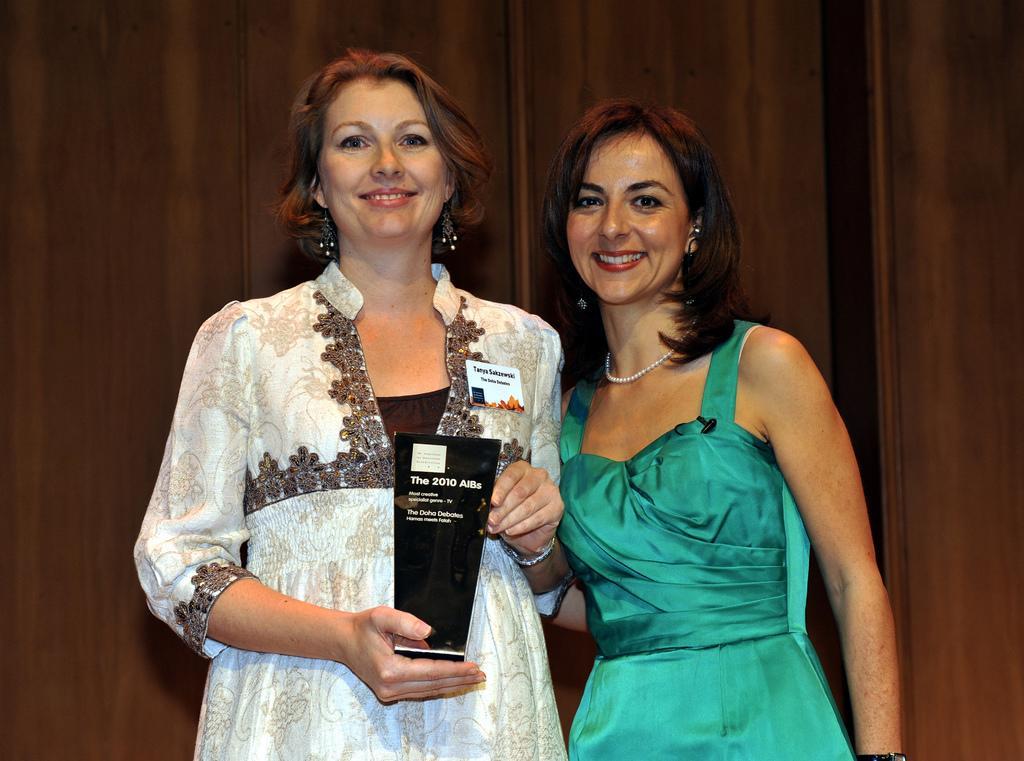Can you describe this image briefly? In this image there are two women standing, there is a woman holding an object, at the background of the image there is a wooden wall. 